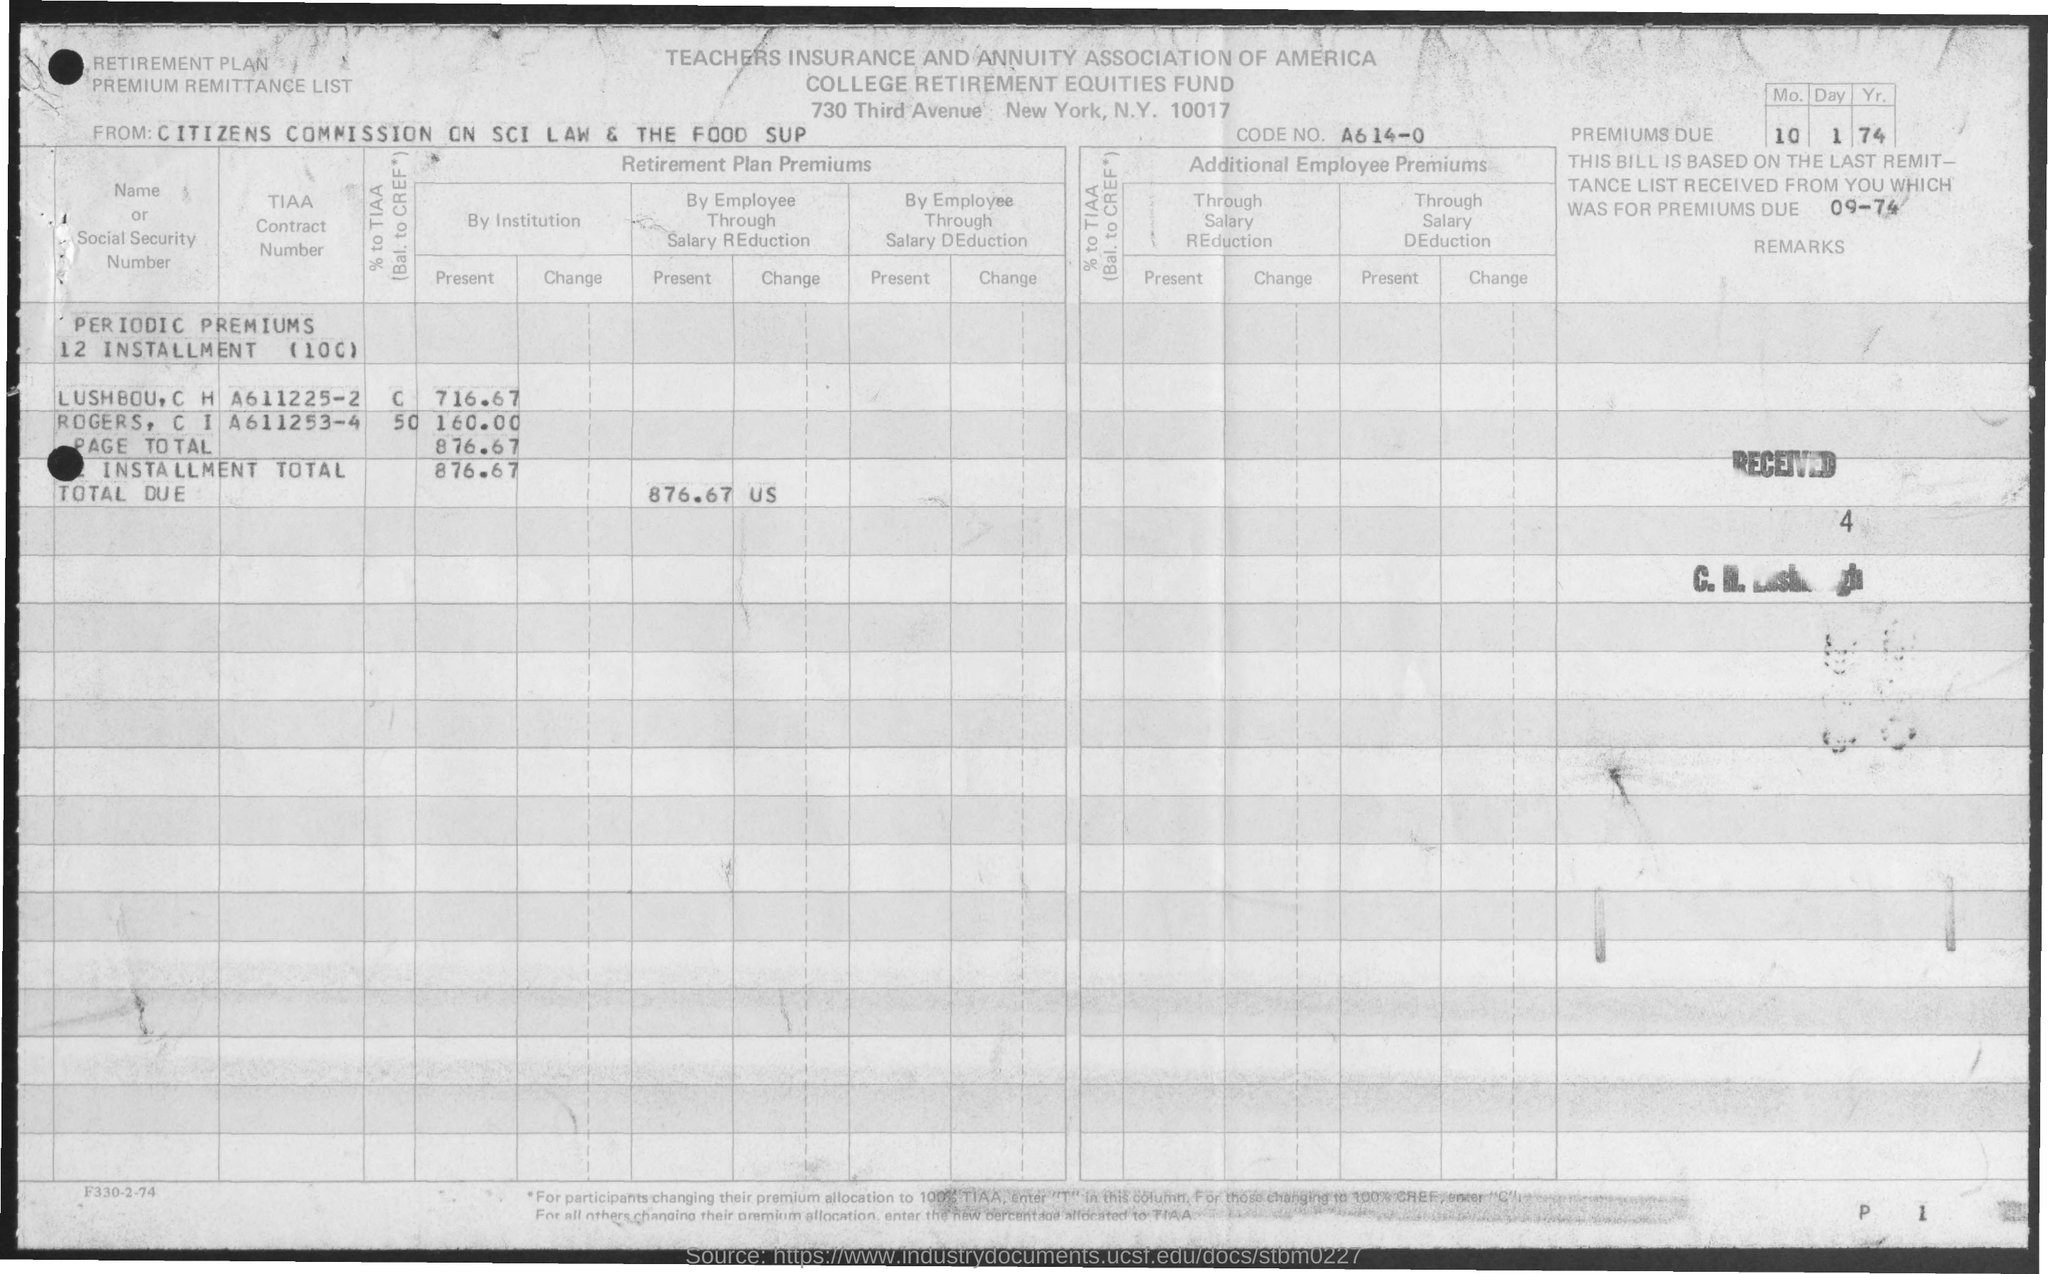List a handful of essential elements in this visual. The TIAA contract number of Rogers, C.I. is A611253-4. The code number is A614-0.. The document's first title is "Teachers Insurance and Annuity Association of America. College Retirement Equities Fund is the second title in the document. The TIAA contract number of Lushbou, C H is A611225-2. 